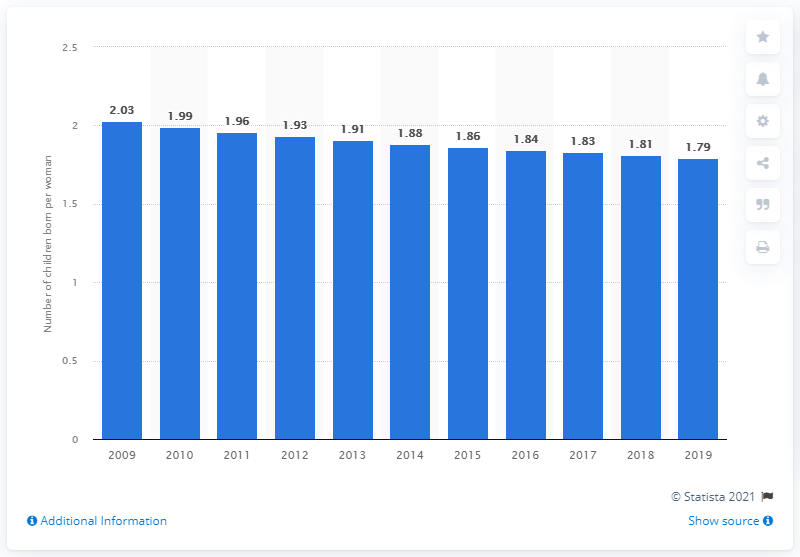Point out several critical features in this image. In 2019, the fertility rate in Colombia was 1.79. 